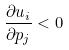Convert formula to latex. <formula><loc_0><loc_0><loc_500><loc_500>\frac { \partial u _ { i } } { \partial p _ { j } } < 0</formula> 